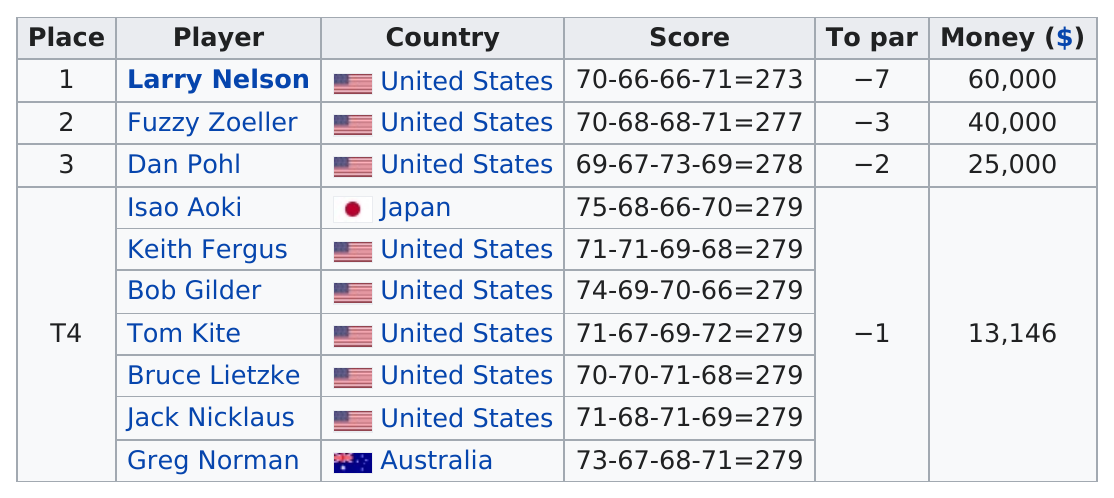Give some essential details in this illustration. According to the given sentence, the difference in score between Fuzzy Zoeller and Larry Nelson was 4. Dan Pohl achieved a first round score of 69. Out of the total number of players who placed fourth, 7 players were identified. In the 1981 PGA Championship, golfer Larry Nelson received the highest amount of money. Isao Aoki trailed Larry Nelson by six strokes in the tournament. 